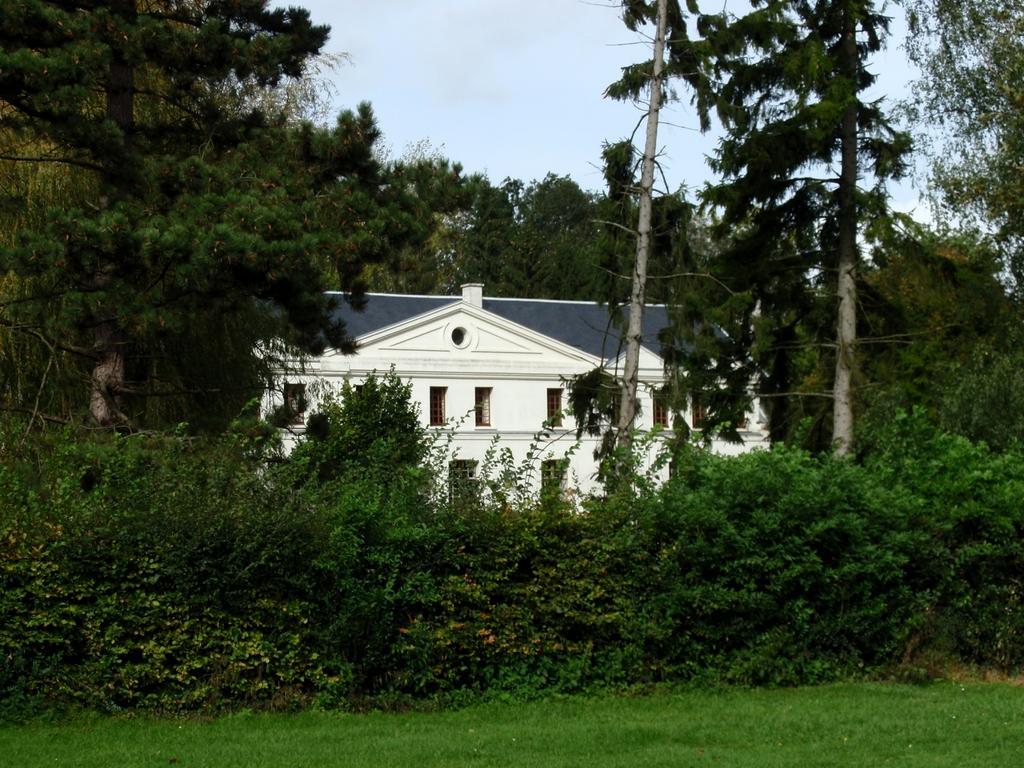Please provide a concise description of this image. In the image there are plants and trees in the front on the grassland and behind there is a building in front of the trees and above its sky. 